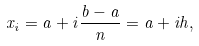<formula> <loc_0><loc_0><loc_500><loc_500>x _ { i } = a + i { \frac { b - a } { n } } = a + i h ,</formula> 